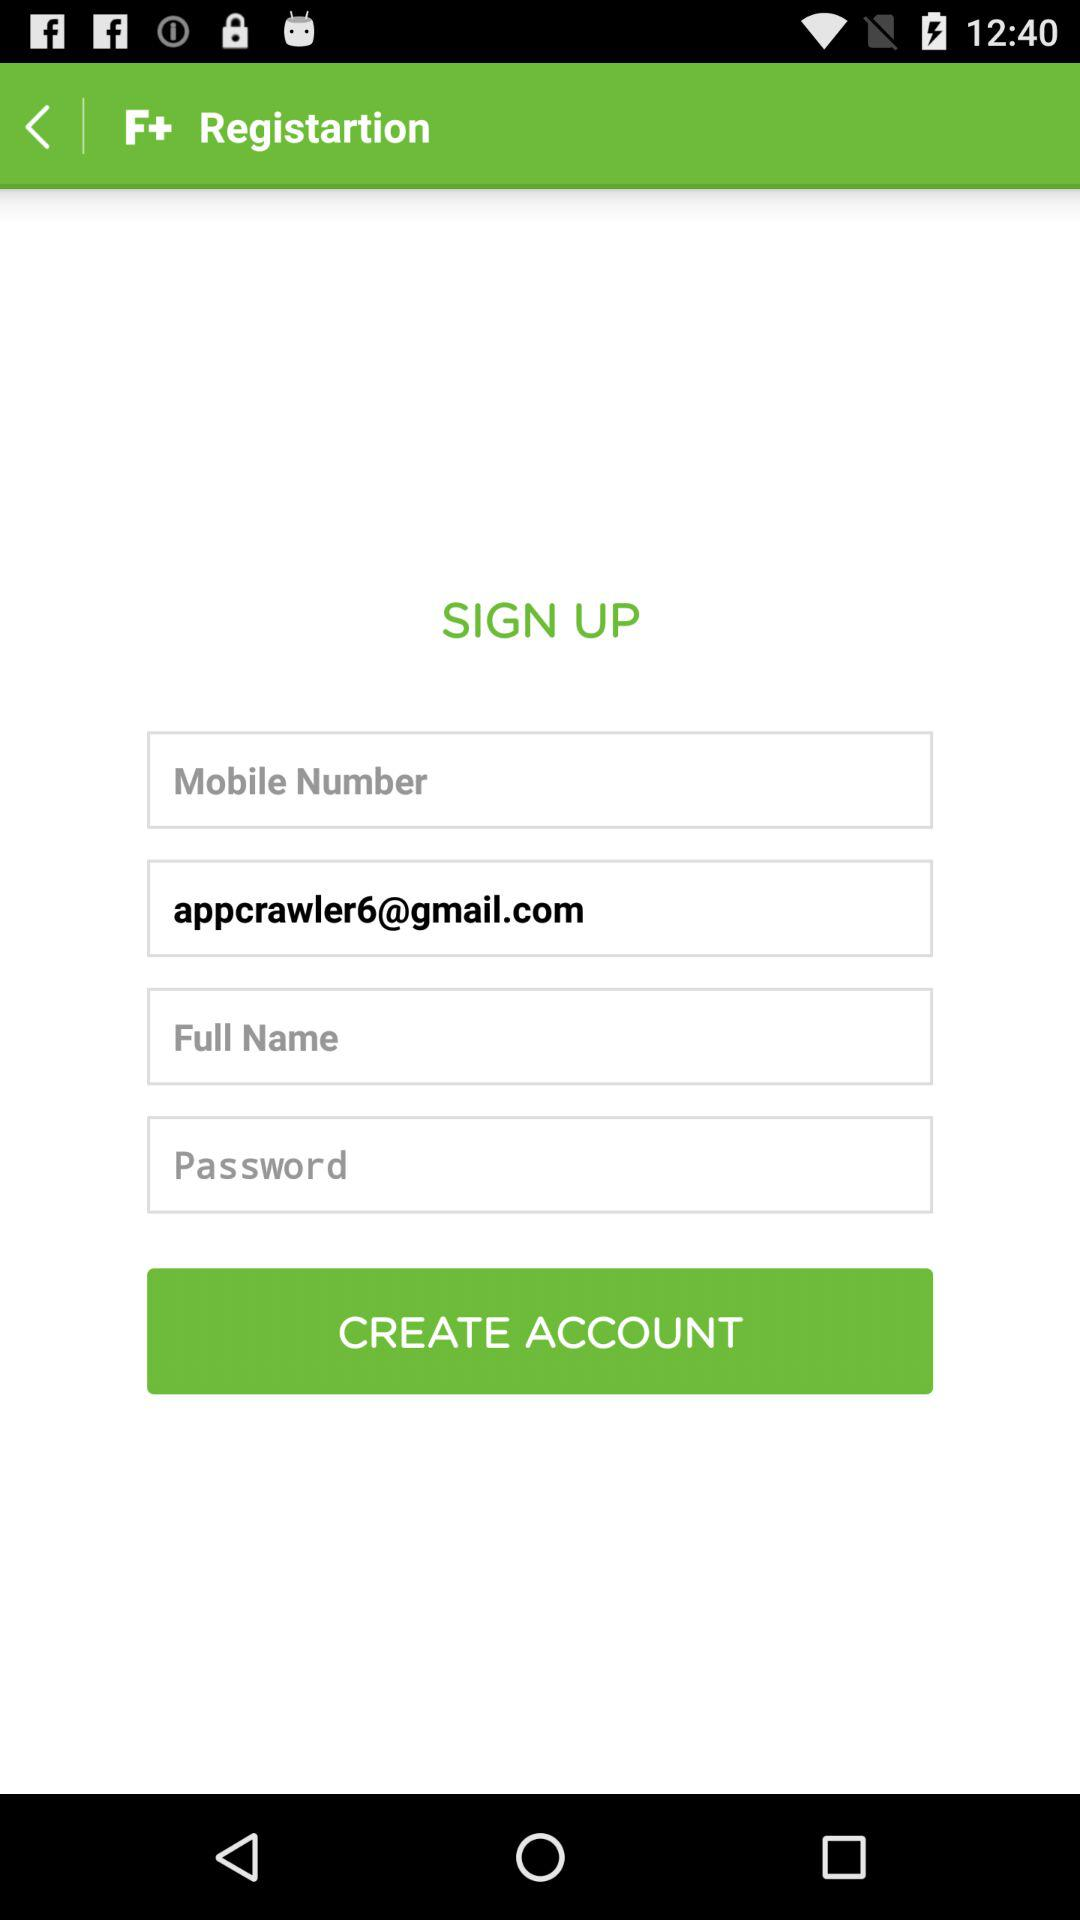What is the email address? The email address is appcrawler6@gmail.com. 